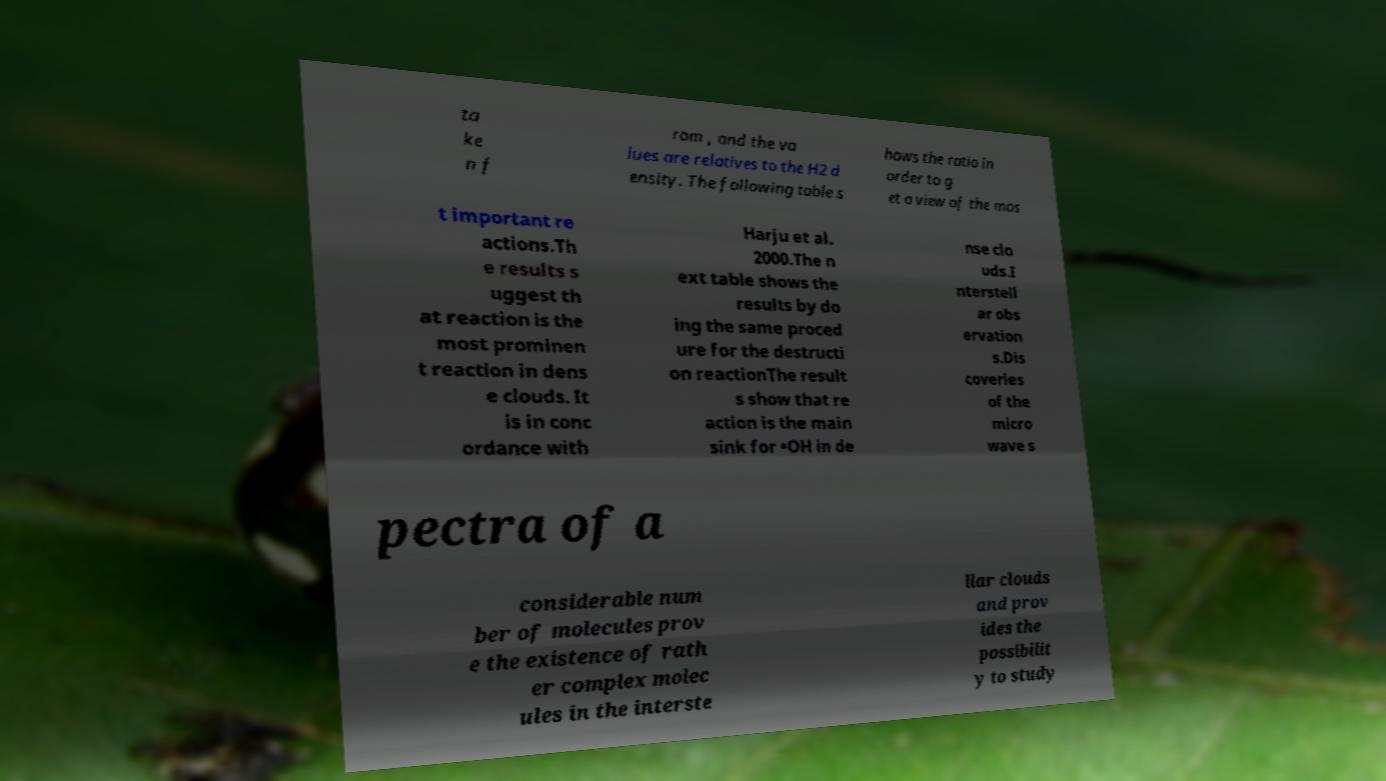Could you assist in decoding the text presented in this image and type it out clearly? ta ke n f rom , and the va lues are relatives to the H2 d ensity. The following table s hows the ratio in order to g et a view of the mos t important re actions.Th e results s uggest th at reaction is the most prominen t reaction in dens e clouds. It is in conc ordance with Harju et al. 2000.The n ext table shows the results by do ing the same proced ure for the destructi on reactionThe result s show that re action is the main sink for •OH in de nse clo uds.I nterstell ar obs ervation s.Dis coveries of the micro wave s pectra of a considerable num ber of molecules prov e the existence of rath er complex molec ules in the interste llar clouds and prov ides the possibilit y to study 